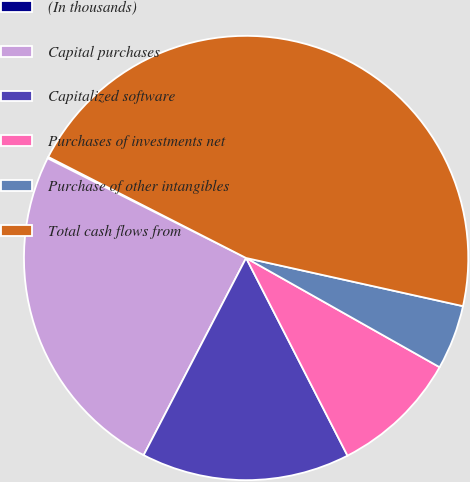Convert chart to OTSL. <chart><loc_0><loc_0><loc_500><loc_500><pie_chart><fcel>(In thousands)<fcel>Capital purchases<fcel>Capitalized software<fcel>Purchases of investments net<fcel>Purchase of other intangibles<fcel>Total cash flows from<nl><fcel>0.11%<fcel>24.78%<fcel>15.17%<fcel>9.28%<fcel>4.7%<fcel>45.96%<nl></chart> 